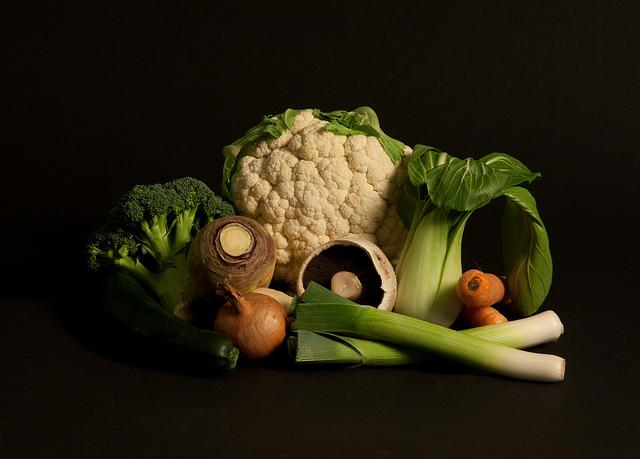Where can these foods be found?

Choices:
A) fast food
B) bar
C) garden
D) office garden 